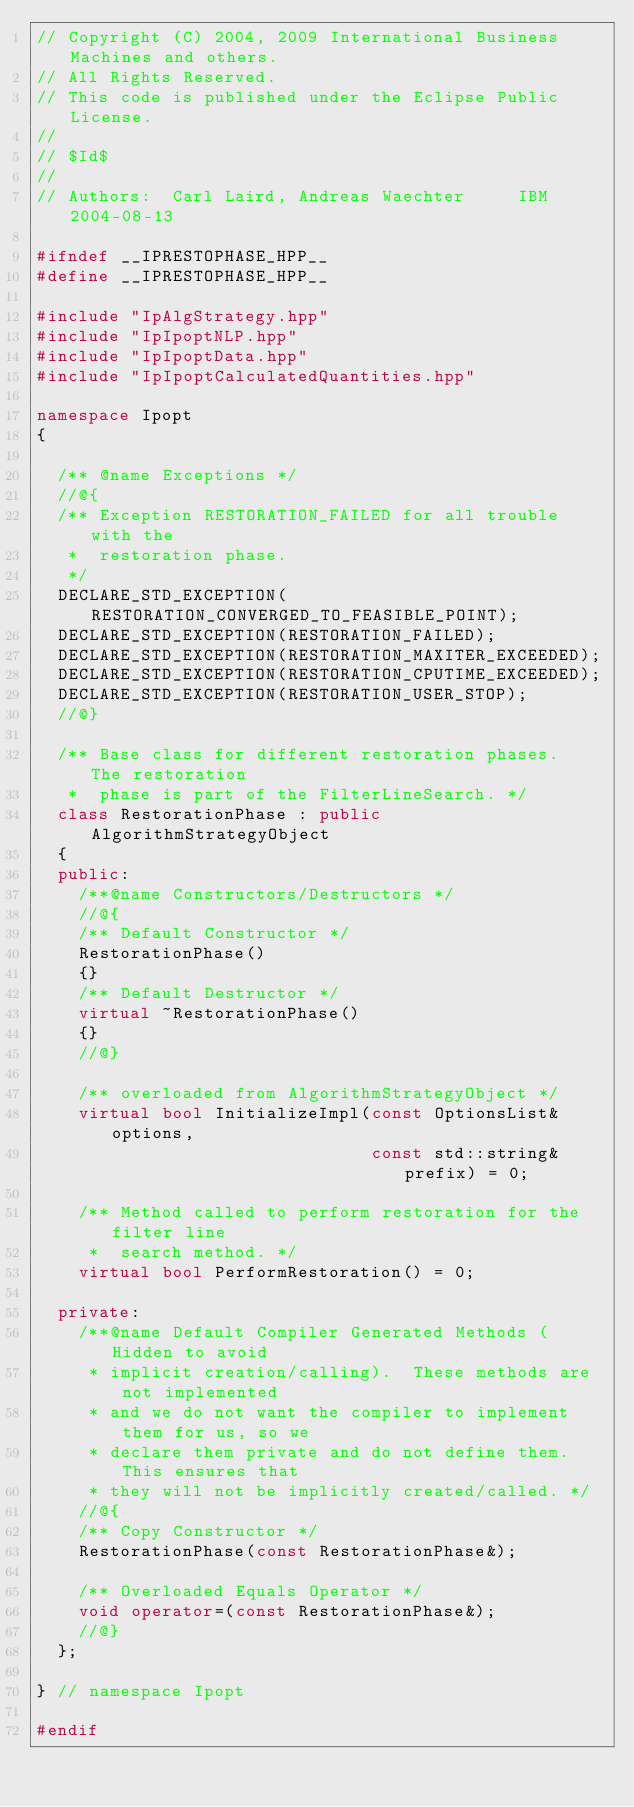<code> <loc_0><loc_0><loc_500><loc_500><_C++_>// Copyright (C) 2004, 2009 International Business Machines and others.
// All Rights Reserved.
// This code is published under the Eclipse Public License.
//
// $Id$
//
// Authors:  Carl Laird, Andreas Waechter     IBM    2004-08-13

#ifndef __IPRESTOPHASE_HPP__
#define __IPRESTOPHASE_HPP__

#include "IpAlgStrategy.hpp"
#include "IpIpoptNLP.hpp"
#include "IpIpoptData.hpp"
#include "IpIpoptCalculatedQuantities.hpp"

namespace Ipopt
{

  /** @name Exceptions */
  //@{
  /** Exception RESTORATION_FAILED for all trouble with the
   *  restoration phase.
   */
  DECLARE_STD_EXCEPTION(RESTORATION_CONVERGED_TO_FEASIBLE_POINT);
  DECLARE_STD_EXCEPTION(RESTORATION_FAILED);
  DECLARE_STD_EXCEPTION(RESTORATION_MAXITER_EXCEEDED);
  DECLARE_STD_EXCEPTION(RESTORATION_CPUTIME_EXCEEDED);
  DECLARE_STD_EXCEPTION(RESTORATION_USER_STOP);
  //@}

  /** Base class for different restoration phases.  The restoration
   *  phase is part of the FilterLineSearch. */
  class RestorationPhase : public AlgorithmStrategyObject
  {
  public:
    /**@name Constructors/Destructors */
    //@{
    /** Default Constructor */
    RestorationPhase()
    {}
    /** Default Destructor */
    virtual ~RestorationPhase()
    {}
    //@}

    /** overloaded from AlgorithmStrategyObject */
    virtual bool InitializeImpl(const OptionsList& options,
                                const std::string& prefix) = 0;

    /** Method called to perform restoration for the filter line
     *  search method. */
    virtual bool PerformRestoration() = 0;

  private:
    /**@name Default Compiler Generated Methods (Hidden to avoid
     * implicit creation/calling).  These methods are not implemented
     * and we do not want the compiler to implement them for us, so we
     * declare them private and do not define them. This ensures that
     * they will not be implicitly created/called. */
    //@{
    /** Copy Constructor */
    RestorationPhase(const RestorationPhase&);

    /** Overloaded Equals Operator */
    void operator=(const RestorationPhase&);
    //@}
  };

} // namespace Ipopt

#endif
</code> 